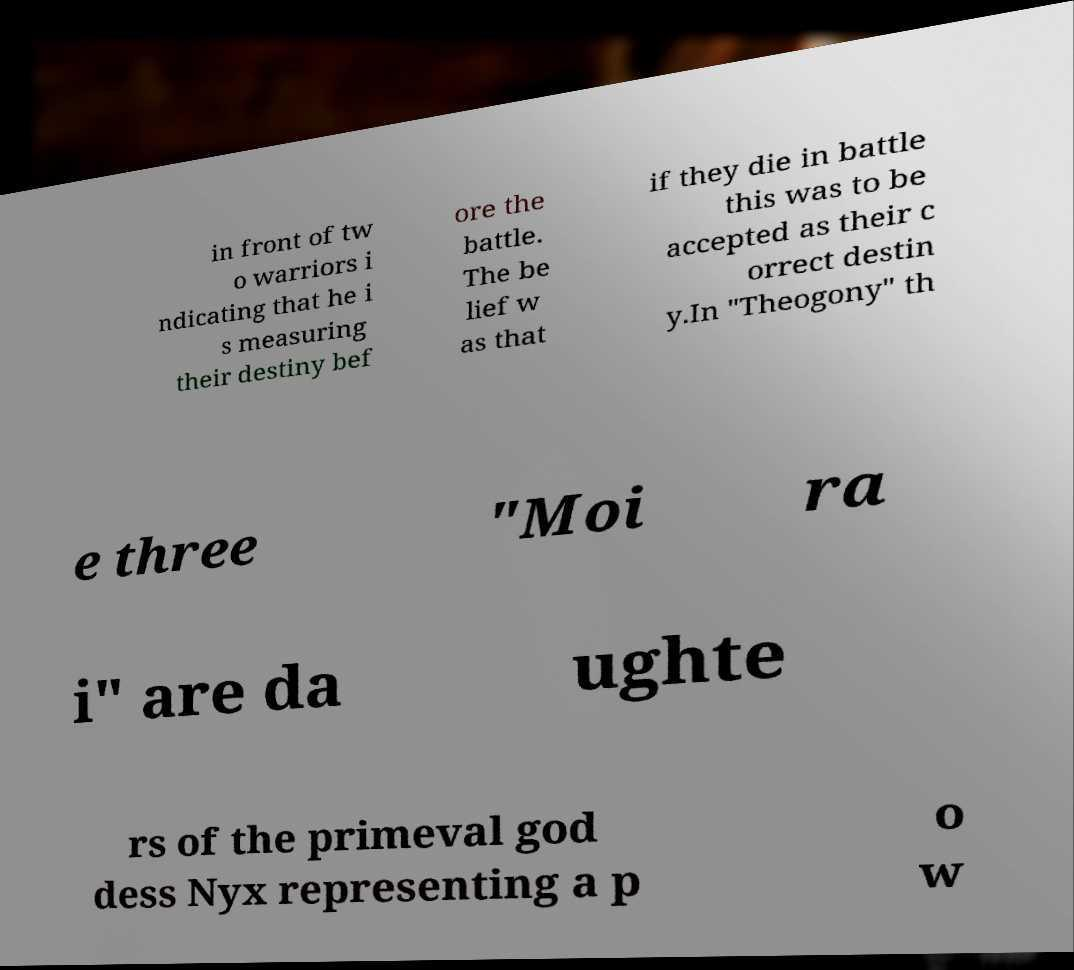What messages or text are displayed in this image? I need them in a readable, typed format. in front of tw o warriors i ndicating that he i s measuring their destiny bef ore the battle. The be lief w as that if they die in battle this was to be accepted as their c orrect destin y.In "Theogony" th e three "Moi ra i" are da ughte rs of the primeval god dess Nyx representing a p o w 